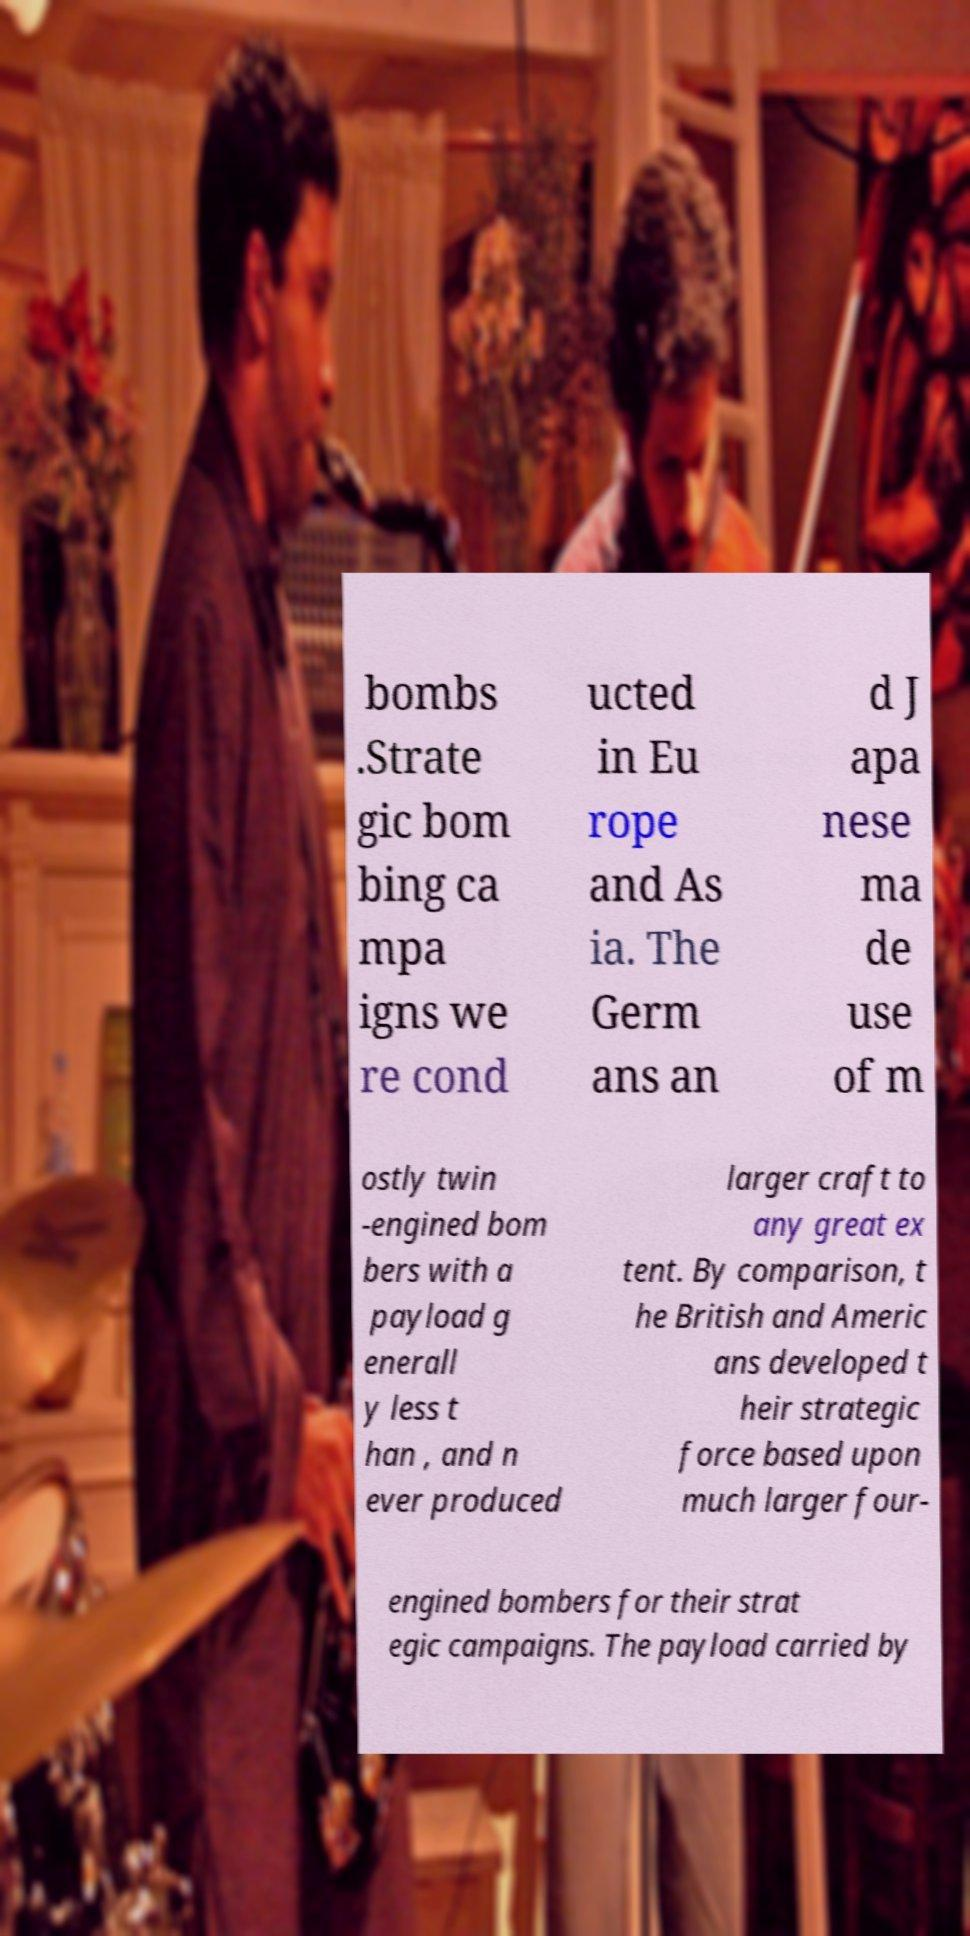What messages or text are displayed in this image? I need them in a readable, typed format. bombs .Strate gic bom bing ca mpa igns we re cond ucted in Eu rope and As ia. The Germ ans an d J apa nese ma de use of m ostly twin -engined bom bers with a payload g enerall y less t han , and n ever produced larger craft to any great ex tent. By comparison, t he British and Americ ans developed t heir strategic force based upon much larger four- engined bombers for their strat egic campaigns. The payload carried by 